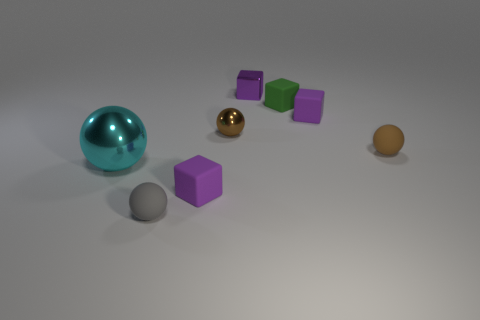Subtract all brown spheres. How many purple cubes are left? 3 Add 1 tiny green matte cubes. How many objects exist? 9 Add 8 big green metal cylinders. How many big green metal cylinders exist? 8 Subtract 0 brown cylinders. How many objects are left? 8 Subtract all tiny matte balls. Subtract all big cyan spheres. How many objects are left? 5 Add 3 green rubber blocks. How many green rubber blocks are left? 4 